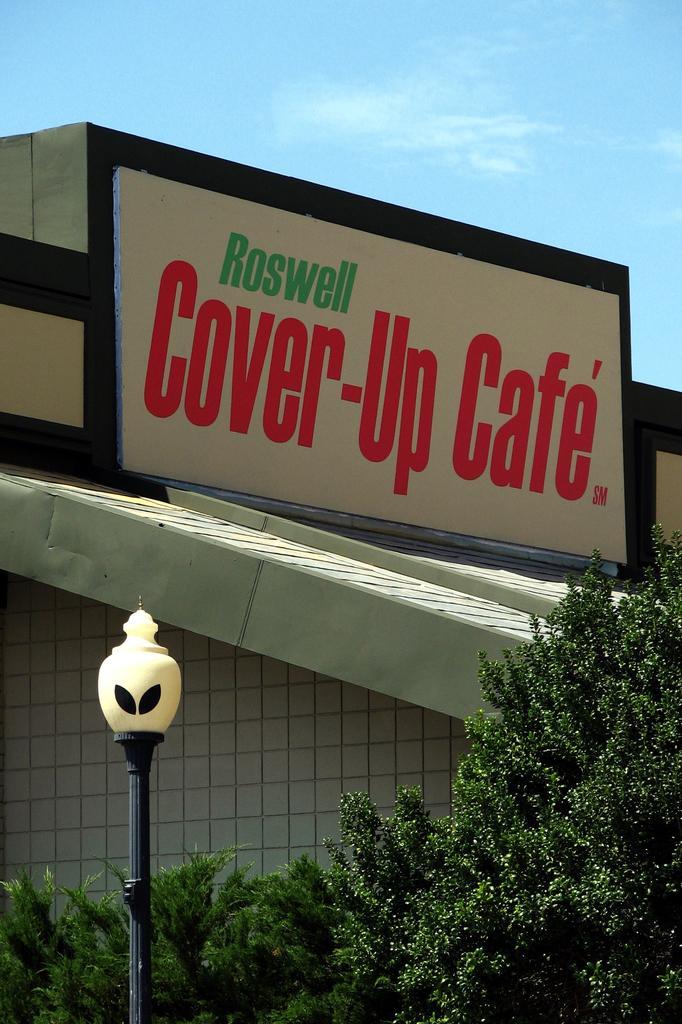In one or two sentences, can you explain what this image depicts? In this image we can see a board with some text, plants, pole, fence and in the background we can see the sky. 